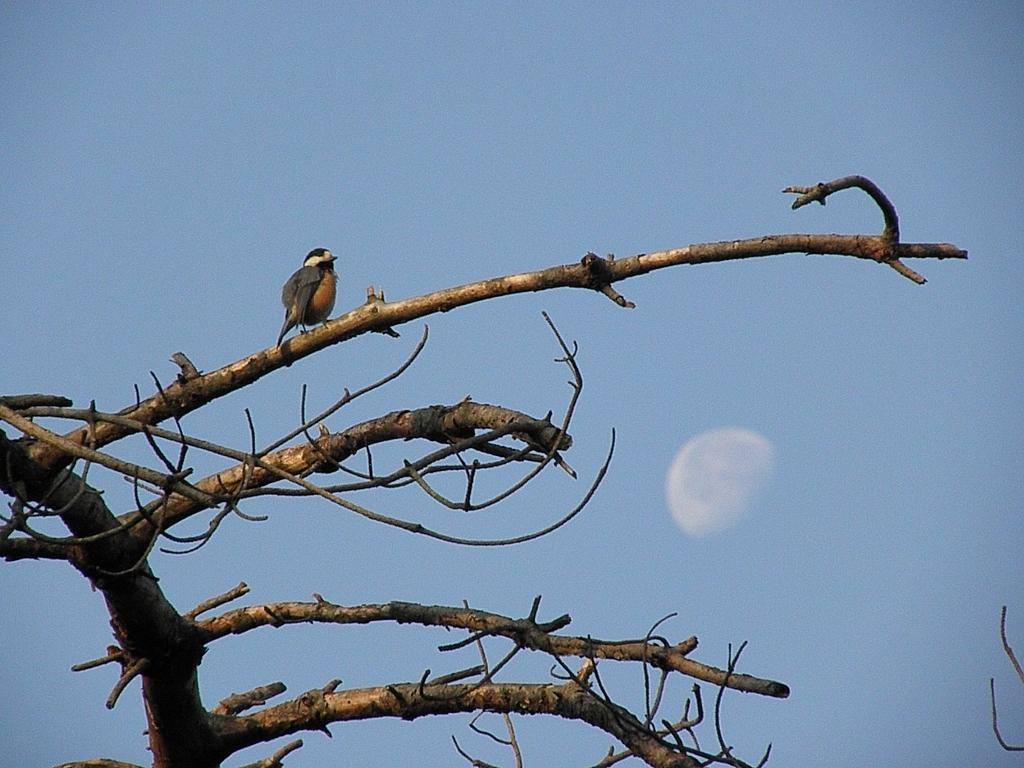What type of animal can be seen in the picture? There is a bird in the picture. Where is the bird located in the image? The bird is sitting on a branch of a tree. What is the main subject in the middle of the image? The tree is in the middle of the image. What is visible at the top of the image? The sky is visible at the top of the image. How many hands are visible in the image? There are no hands visible in the image. What type of wire is being used by the bird in the image? There is no wire present in the image; the bird is sitting on a branch of a tree. 